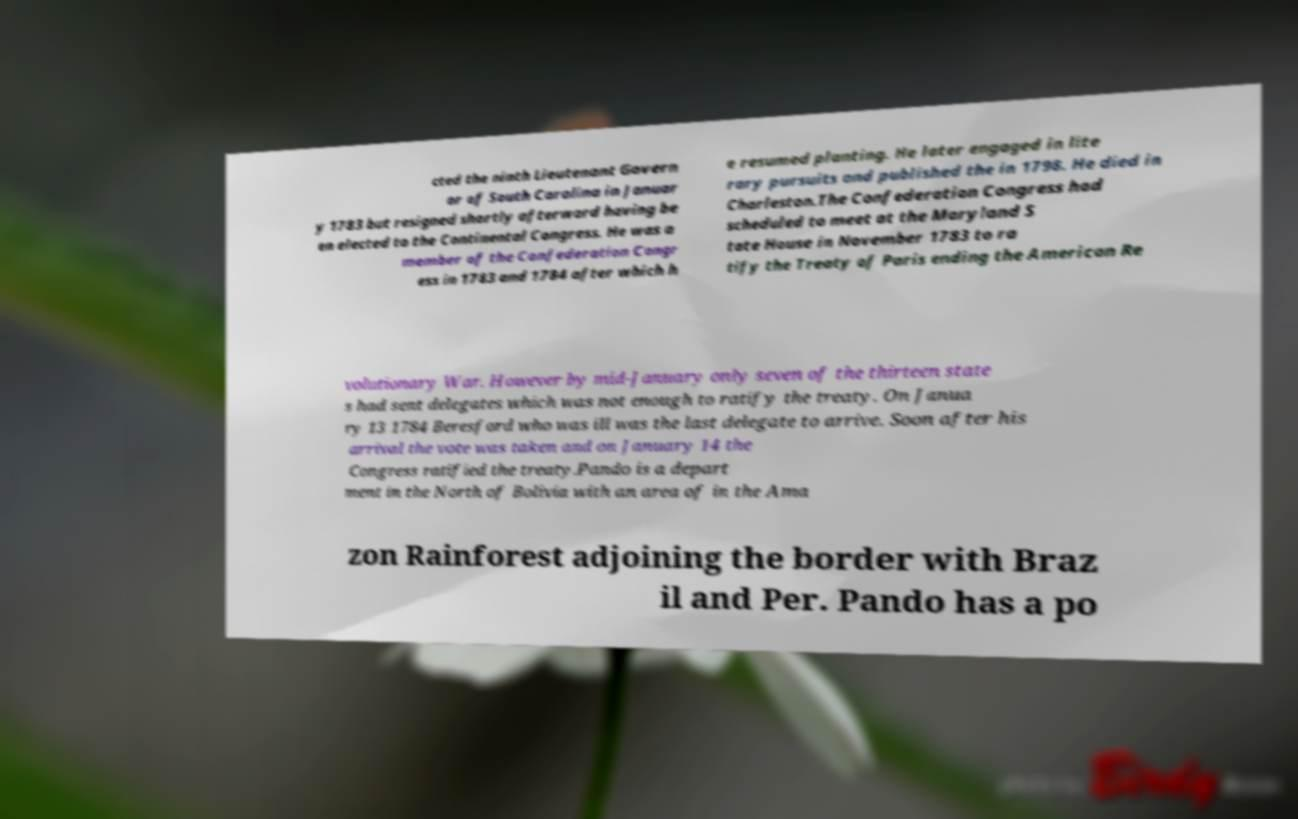For documentation purposes, I need the text within this image transcribed. Could you provide that? cted the ninth Lieutenant Govern or of South Carolina in Januar y 1783 but resigned shortly afterward having be en elected to the Continental Congress. He was a member of the Confederation Congr ess in 1783 and 1784 after which h e resumed planting. He later engaged in lite rary pursuits and published the in 1798. He died in Charleston.The Confederation Congress had scheduled to meet at the Maryland S tate House in November 1783 to ra tify the Treaty of Paris ending the American Re volutionary War. However by mid-January only seven of the thirteen state s had sent delegates which was not enough to ratify the treaty. On Janua ry 13 1784 Beresford who was ill was the last delegate to arrive. Soon after his arrival the vote was taken and on January 14 the Congress ratified the treaty.Pando is a depart ment in the North of Bolivia with an area of in the Ama zon Rainforest adjoining the border with Braz il and Per. Pando has a po 